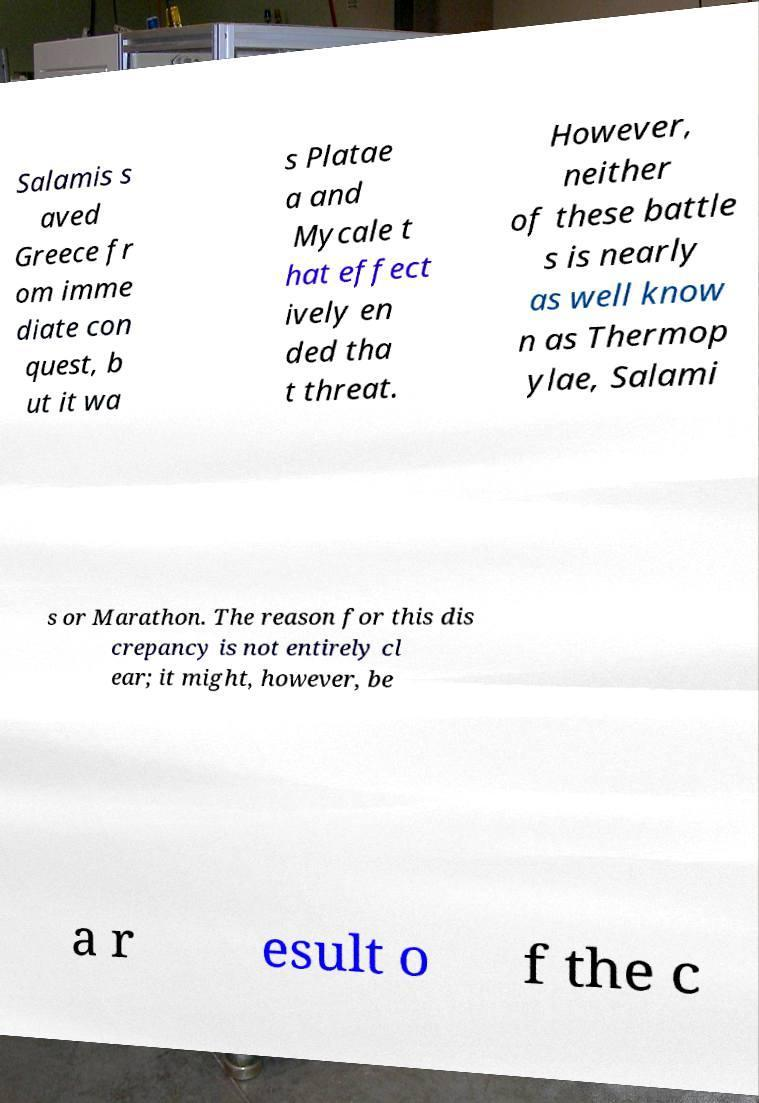Can you accurately transcribe the text from the provided image for me? Salamis s aved Greece fr om imme diate con quest, b ut it wa s Platae a and Mycale t hat effect ively en ded tha t threat. However, neither of these battle s is nearly as well know n as Thermop ylae, Salami s or Marathon. The reason for this dis crepancy is not entirely cl ear; it might, however, be a r esult o f the c 